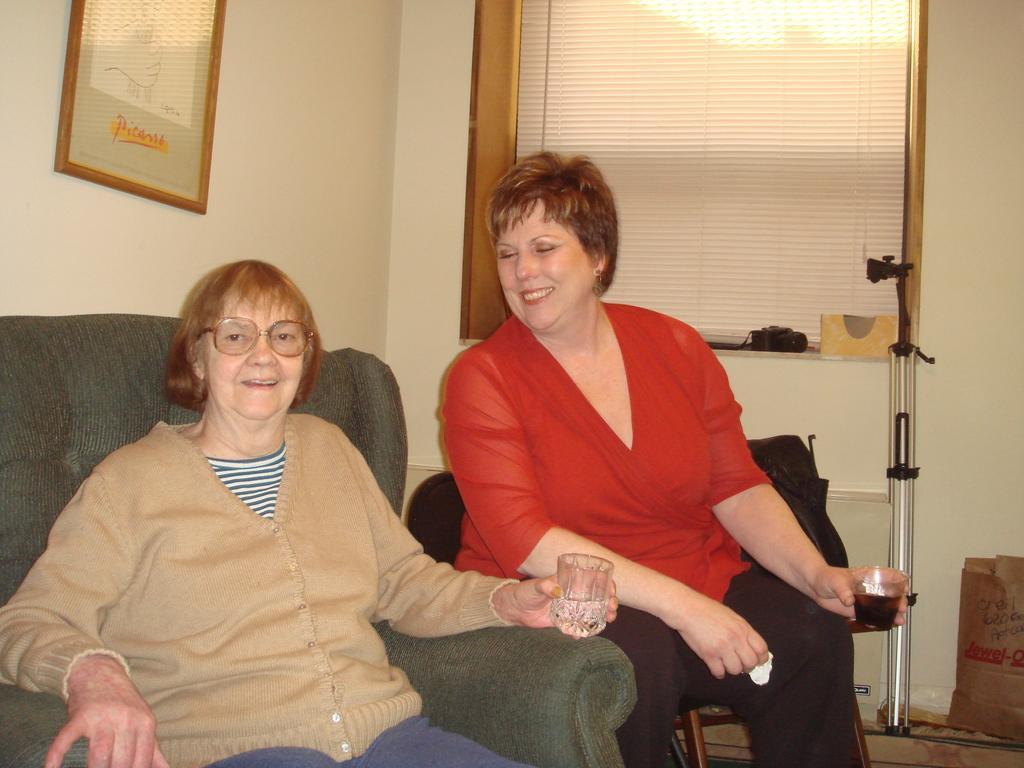Describe this image in one or two sentences. In this picture we can see two women,they are holding glasses and in the background we can see a wall,photo frame. 